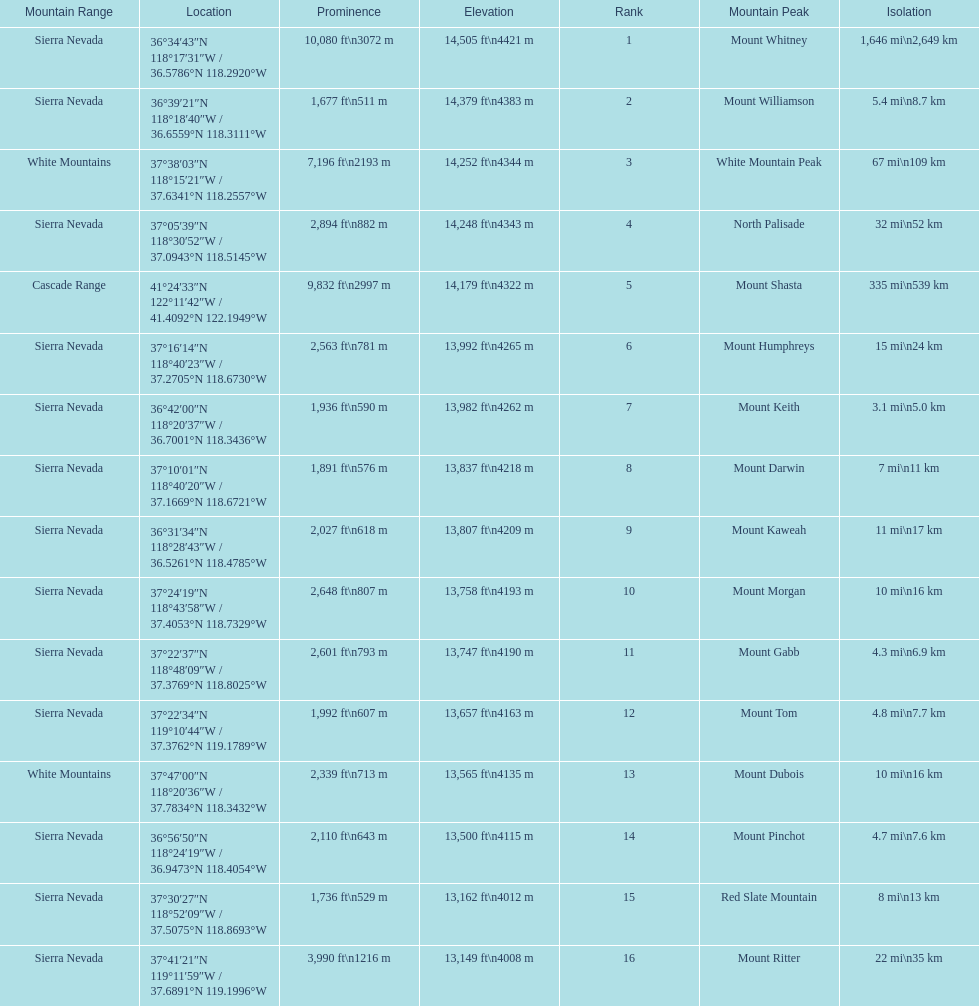What is the total elevation (in ft) of mount whitney? 14,505 ft. 